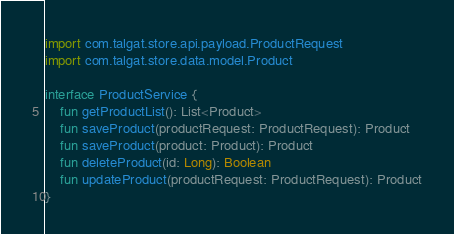Convert code to text. <code><loc_0><loc_0><loc_500><loc_500><_Kotlin_>
import com.talgat.store.api.payload.ProductRequest
import com.talgat.store.data.model.Product

interface ProductService {
    fun getProductList(): List<Product>
    fun saveProduct(productRequest: ProductRequest): Product
    fun saveProduct(product: Product): Product
    fun deleteProduct(id: Long): Boolean
    fun updateProduct(productRequest: ProductRequest): Product
}
</code> 